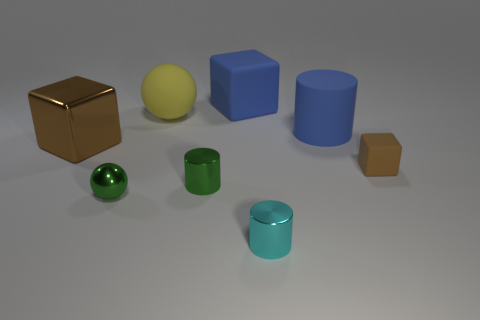Subtract all brown cubes. How many cubes are left? 1 Add 1 yellow matte cubes. How many objects exist? 9 Subtract all blue blocks. How many blocks are left? 2 Subtract 2 spheres. How many spheres are left? 0 Add 8 large brown things. How many large brown things are left? 9 Add 8 blue objects. How many blue objects exist? 10 Subtract 1 blue cubes. How many objects are left? 7 Subtract all cylinders. How many objects are left? 5 Subtract all cyan spheres. Subtract all blue cylinders. How many spheres are left? 2 Subtract all yellow cylinders. How many brown cubes are left? 2 